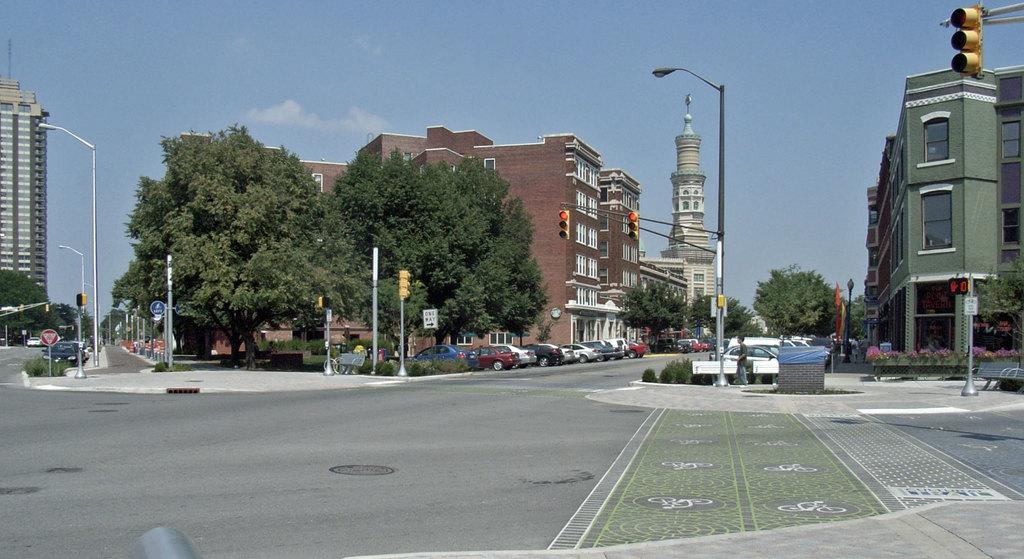What type of structures can be seen in the image? There are buildings and houses in the image. What natural elements are present in the image? There are trees and plants in the image. What man-made objects can be seen in the image? There are poles in the image. Are there any living beings in the image? Yes, there are people in the image. What type of cow can be seen grazing in the image? There is no cow present in the image. Can you recall the weather conditions during the time the image was taken? The provided facts do not mention any weather conditions, so it is not possible to determine the weather from the image. 